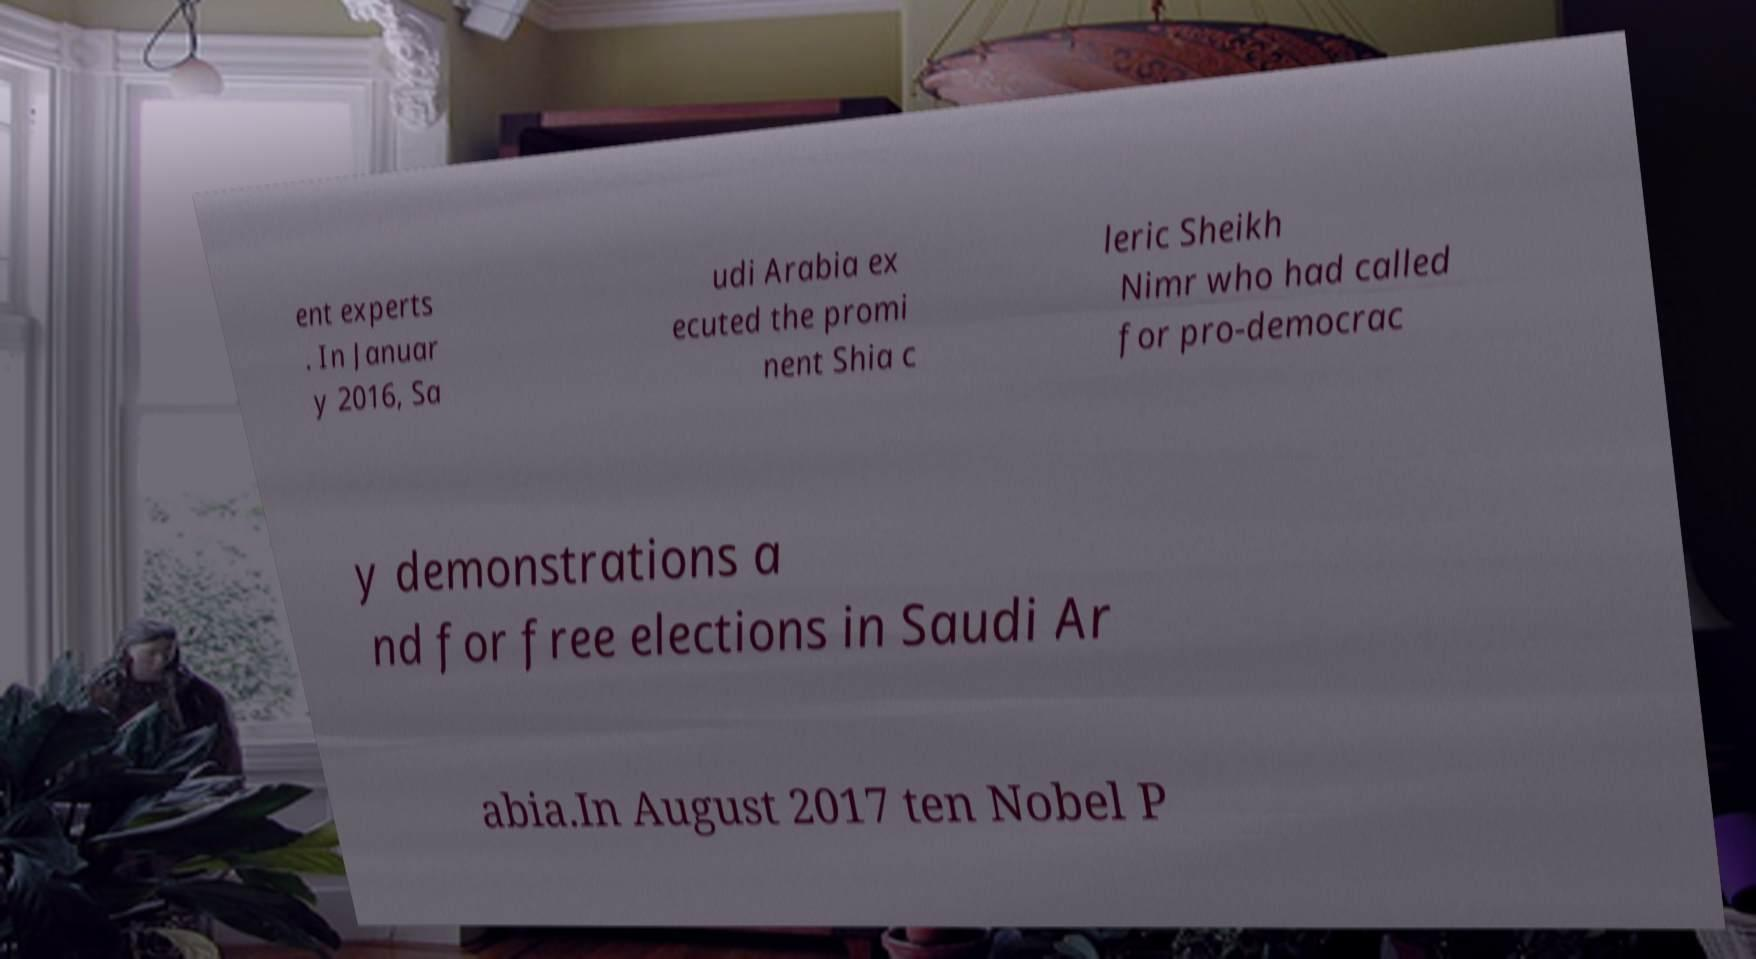Could you assist in decoding the text presented in this image and type it out clearly? ent experts . In Januar y 2016, Sa udi Arabia ex ecuted the promi nent Shia c leric Sheikh Nimr who had called for pro-democrac y demonstrations a nd for free elections in Saudi Ar abia.In August 2017 ten Nobel P 